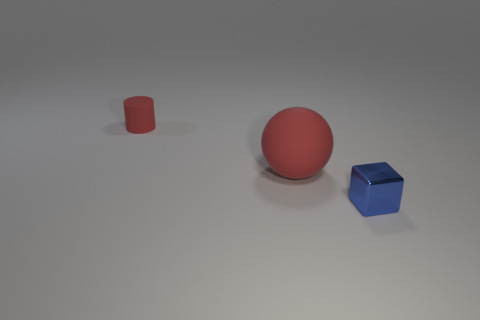Add 1 tiny red rubber cylinders. How many objects exist? 4 Subtract all cubes. How many objects are left? 2 Subtract all brown metallic things. Subtract all matte cylinders. How many objects are left? 2 Add 3 large red rubber spheres. How many large red rubber spheres are left? 4 Add 1 tiny objects. How many tiny objects exist? 3 Subtract 0 brown cylinders. How many objects are left? 3 